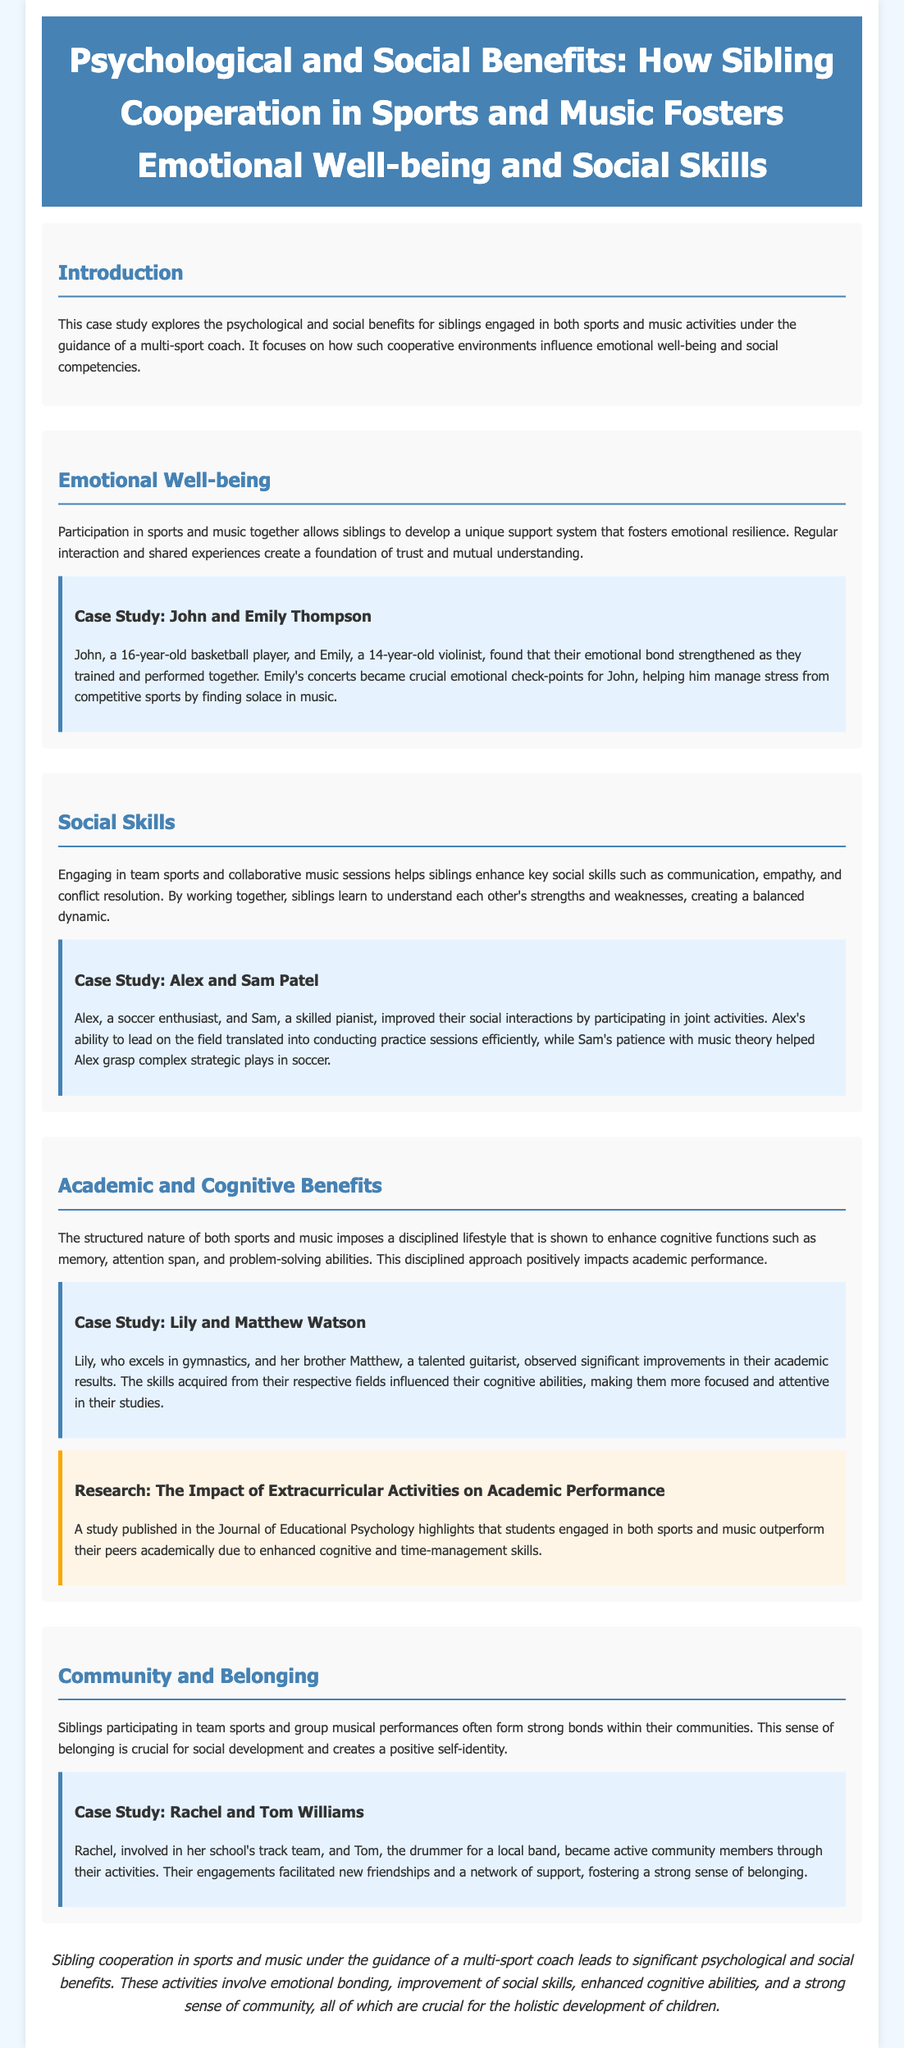What is the primary focus of the case study? The case study explores the psychological and social benefits for siblings engaged in sports and music activities under the guidance of a multi-sport coach.
Answer: Psychological and social benefits Who are the siblings in the emotional well-being case study? The emotional well-being section features a case study about John and Emily Thompson.
Answer: John and Emily Thompson What activity does Sam Patel excel in? In the social skills section, it is mentioned that Sam is a skilled pianist.
Answer: Pianist What improvement did Lily and Matthew Watson observe in their studies? The academic and cognitive benefits section states that Lily and Matthew observed significant improvements in their academic results.
Answer: Significant improvements What is one key social skill enhanced by sibling cooperation in sports and music? The document mentions communication as one of the key social skills enhanced through sibling cooperation.
Answer: Communication Which activity helped John manage stress from sports? According to the document, Emily's concerts became crucial emotional check-points for John to manage stress.
Answer: Concerts What sense do siblings gain through participation in team sports and performances? The document states that siblings often form a strong sense of belonging within their communities.
Answer: Belonging What is the role of a multi-sport coach in this case study? The case study emphasizes the guidance from a multi-sport coach for the siblings engaged in sports and music activities.
Answer: Guidance How does participation in sports and music affect cognitive functions? The structured nature of sports and music is shown to enhance cognitive functions such as memory, attention span, and problem-solving abilities.
Answer: Enhances cognitive functions 